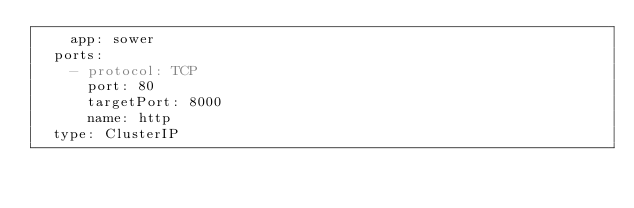Convert code to text. <code><loc_0><loc_0><loc_500><loc_500><_YAML_>    app: sower
  ports:
    - protocol: TCP
      port: 80
      targetPort: 8000
      name: http
  type: ClusterIP
</code> 